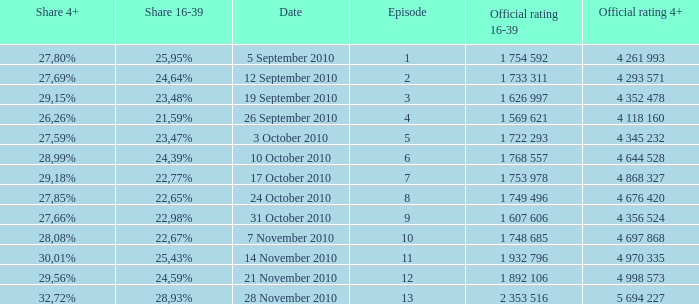What is the official 4+ rating of the episode with a 16-39 share of 24,59%? 4 998 573. 